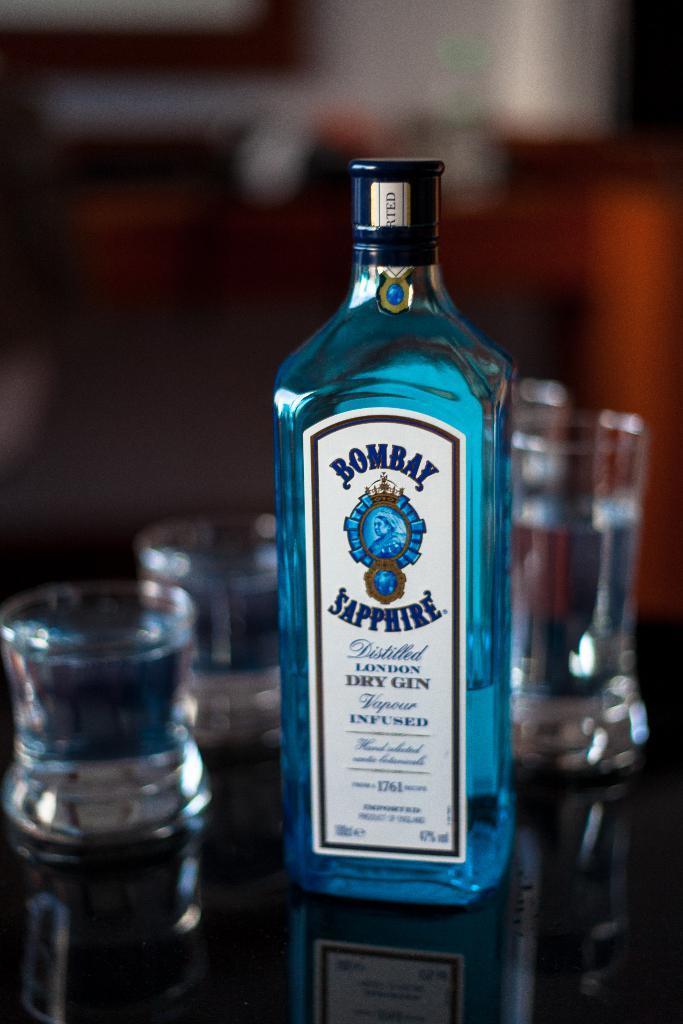In one or two sentences, can you explain what this image depicts? This image consists of glasses and bottle. On the bottle there is a Bombay Sapphire written on it. In that there is a blue color liquid. 